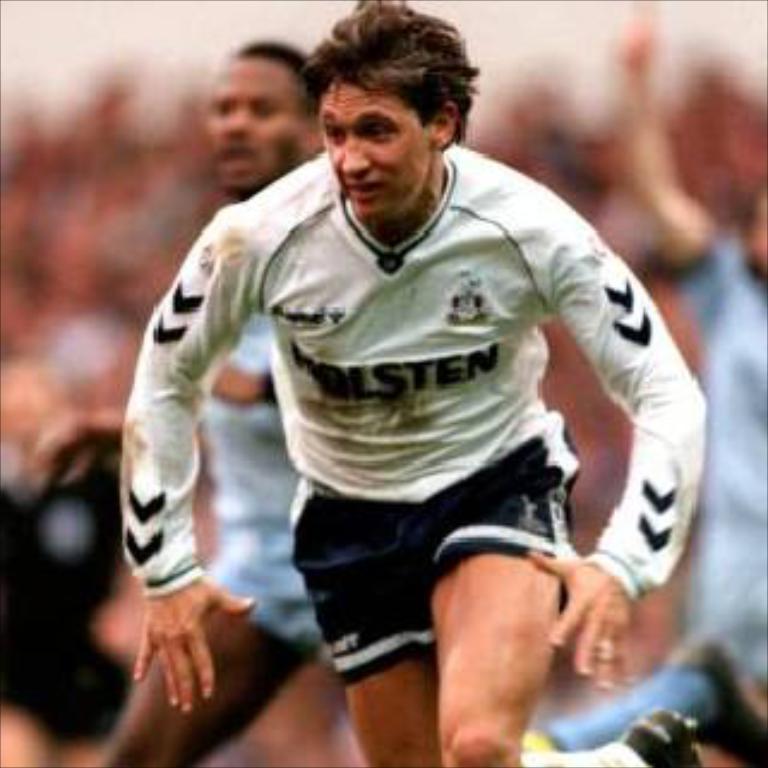Can you describe this image briefly? In this image we can see a person running and behind him we can see some people. 